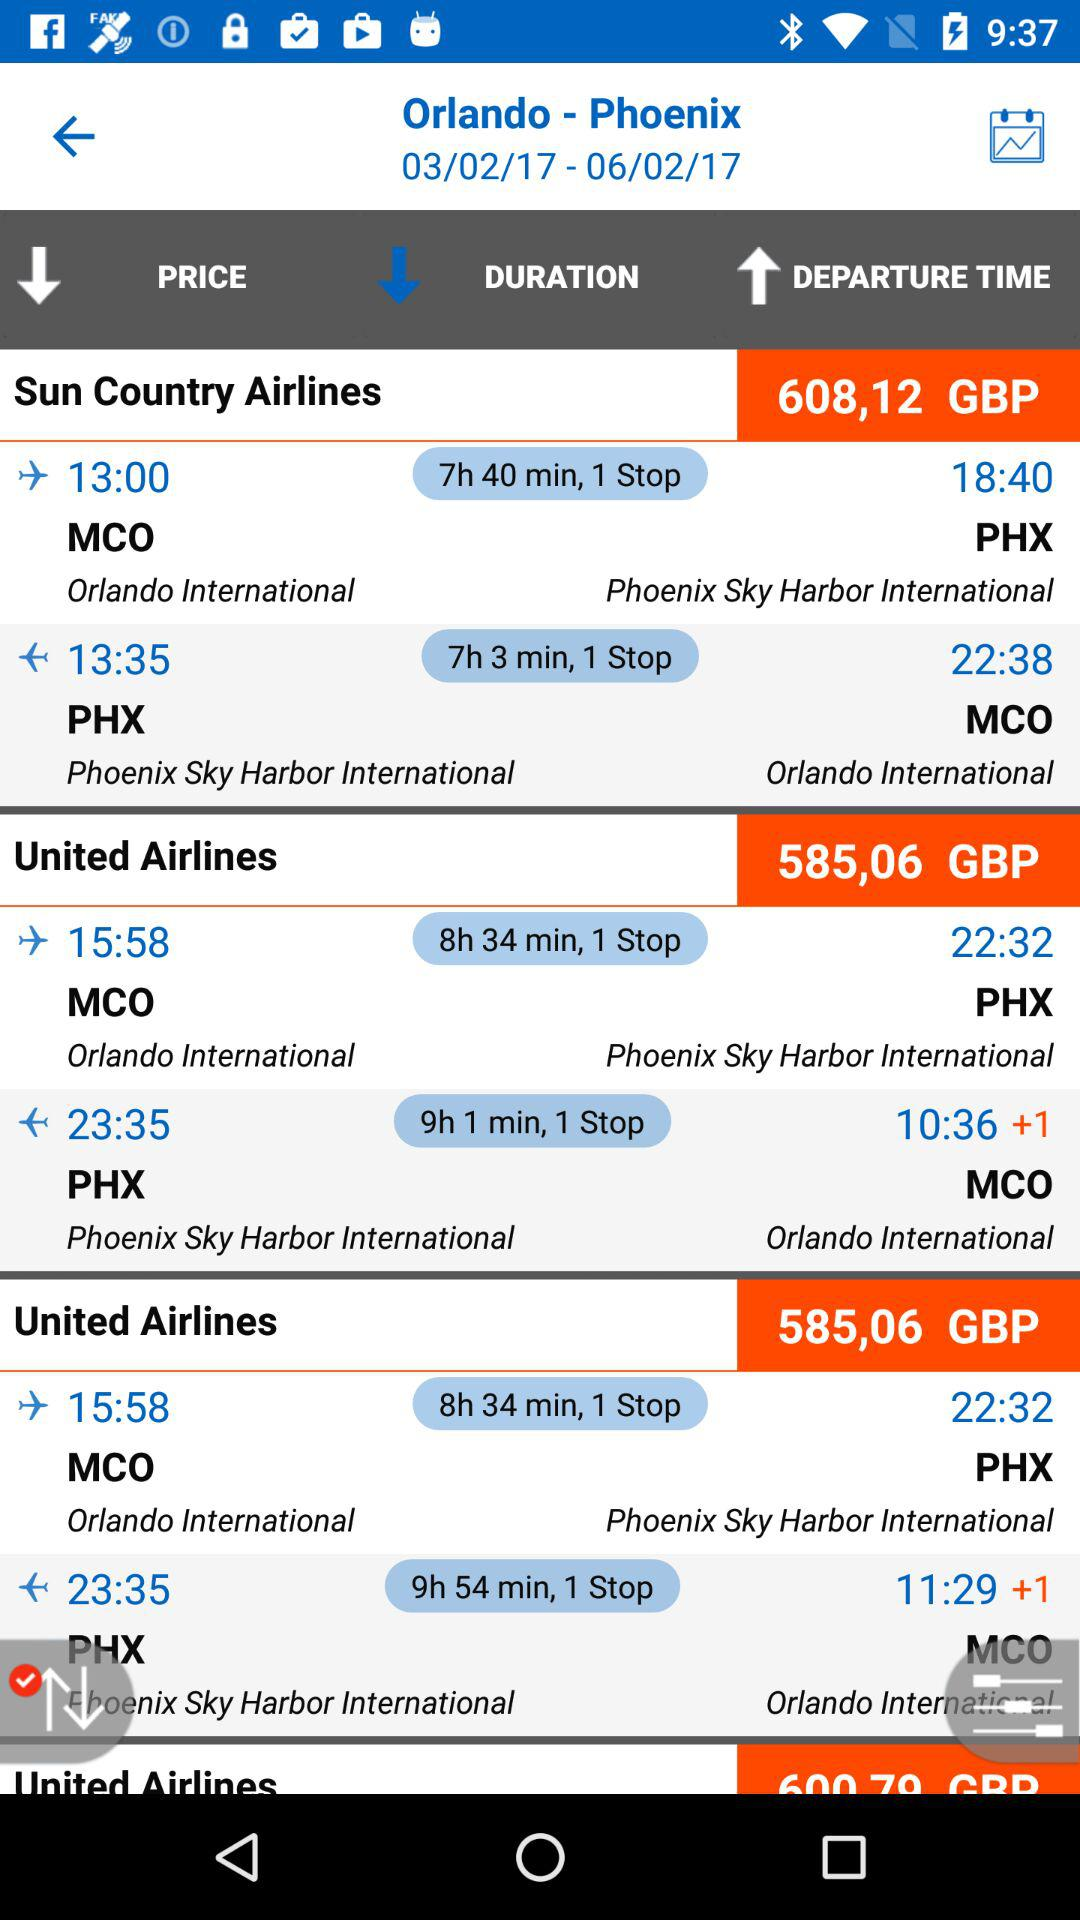How long is the duration from Phoenix Sky Harbor International Airport to Orlando International Airport? The durations are 7 hours and 3 minutes, 9 hours and 1 minute and 9 hours and 54 minutes. 